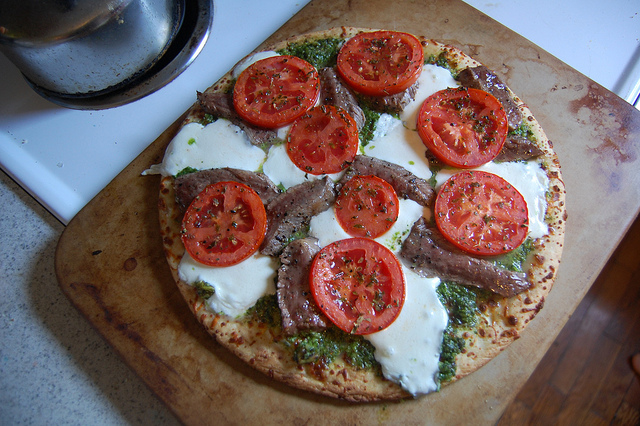<image>What paste is used to make this pizza? I am not sure what paste is used to make this pizza. It can be tomato paste, pesto, cheese paste or no paste. What paste is used to make this pizza? It is unanswerable what paste is used to make this pizza. 